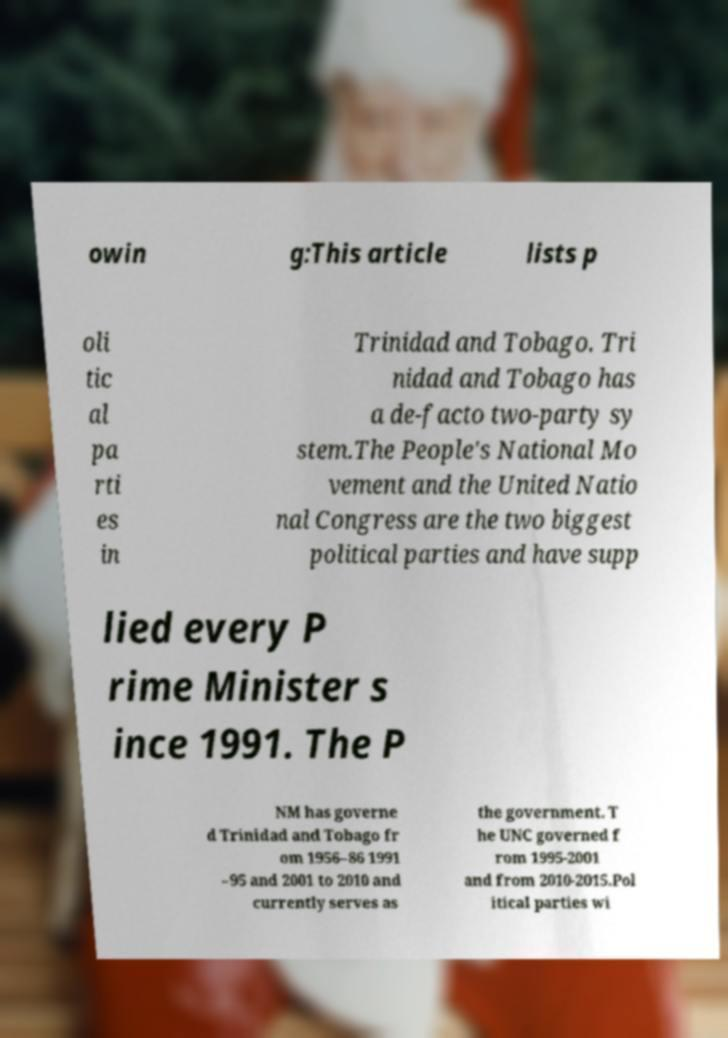I need the written content from this picture converted into text. Can you do that? owin g:This article lists p oli tic al pa rti es in Trinidad and Tobago. Tri nidad and Tobago has a de-facto two-party sy stem.The People's National Mo vement and the United Natio nal Congress are the two biggest political parties and have supp lied every P rime Minister s ince 1991. The P NM has governe d Trinidad and Tobago fr om 1956–86 1991 –95 and 2001 to 2010 and currently serves as the government. T he UNC governed f rom 1995-2001 and from 2010-2015.Pol itical parties wi 